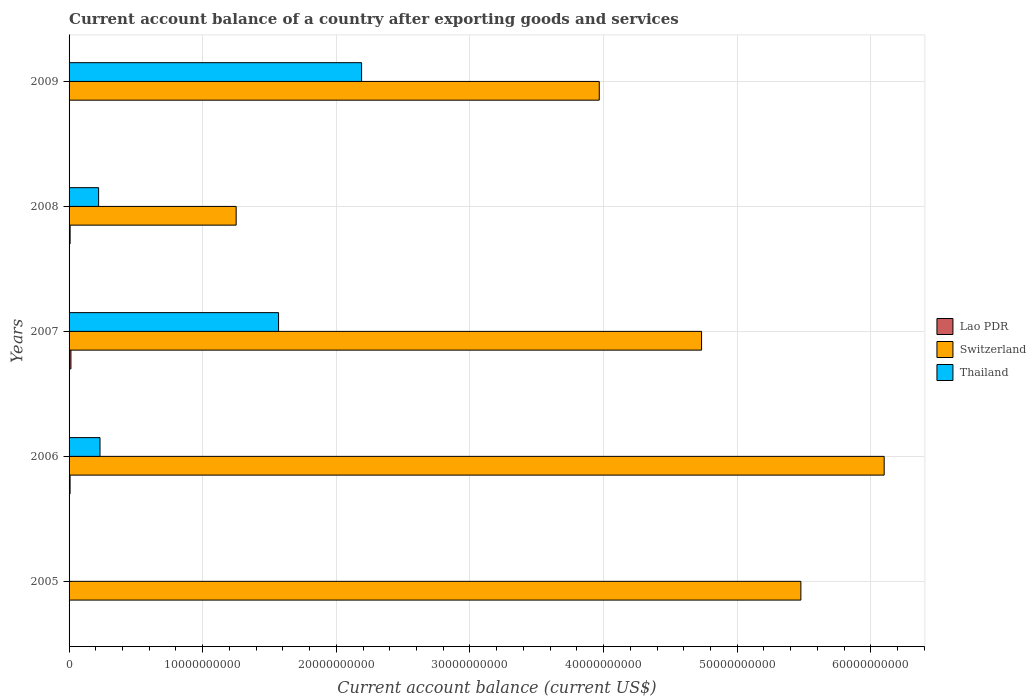How many different coloured bars are there?
Provide a short and direct response. 3. Are the number of bars per tick equal to the number of legend labels?
Your answer should be compact. No. What is the account balance in Switzerland in 2006?
Make the answer very short. 6.10e+1. Across all years, what is the maximum account balance in Lao PDR?
Your response must be concise. 1.39e+08. Across all years, what is the minimum account balance in Lao PDR?
Ensure brevity in your answer.  0. What is the total account balance in Lao PDR in the graph?
Provide a short and direct response. 2.92e+08. What is the difference between the account balance in Switzerland in 2007 and that in 2008?
Offer a very short reply. 3.48e+1. What is the difference between the account balance in Thailand in 2005 and the account balance in Lao PDR in 2009?
Offer a terse response. 0. What is the average account balance in Thailand per year?
Offer a terse response. 8.42e+09. In the year 2009, what is the difference between the account balance in Switzerland and account balance in Thailand?
Your answer should be very brief. 1.78e+1. In how many years, is the account balance in Switzerland greater than 52000000000 US$?
Ensure brevity in your answer.  2. What is the ratio of the account balance in Lao PDR in 2006 to that in 2008?
Offer a very short reply. 0.97. What is the difference between the highest and the second highest account balance in Switzerland?
Make the answer very short. 6.23e+09. What is the difference between the highest and the lowest account balance in Lao PDR?
Make the answer very short. 1.39e+08. Is it the case that in every year, the sum of the account balance in Switzerland and account balance in Lao PDR is greater than the account balance in Thailand?
Your response must be concise. Yes. How many bars are there?
Your answer should be very brief. 12. Are all the bars in the graph horizontal?
Make the answer very short. Yes. How many years are there in the graph?
Your answer should be compact. 5. What is the difference between two consecutive major ticks on the X-axis?
Offer a very short reply. 1.00e+1. Are the values on the major ticks of X-axis written in scientific E-notation?
Keep it short and to the point. No. Does the graph contain any zero values?
Provide a short and direct response. Yes. Does the graph contain grids?
Ensure brevity in your answer.  Yes. Where does the legend appear in the graph?
Make the answer very short. Center right. How many legend labels are there?
Keep it short and to the point. 3. How are the legend labels stacked?
Offer a very short reply. Vertical. What is the title of the graph?
Make the answer very short. Current account balance of a country after exporting goods and services. Does "Kuwait" appear as one of the legend labels in the graph?
Give a very brief answer. No. What is the label or title of the X-axis?
Your answer should be very brief. Current account balance (current US$). What is the Current account balance (current US$) of Lao PDR in 2005?
Provide a succinct answer. 0. What is the Current account balance (current US$) in Switzerland in 2005?
Your response must be concise. 5.48e+1. What is the Current account balance (current US$) of Lao PDR in 2006?
Your answer should be very brief. 7.53e+07. What is the Current account balance (current US$) in Switzerland in 2006?
Keep it short and to the point. 6.10e+1. What is the Current account balance (current US$) in Thailand in 2006?
Keep it short and to the point. 2.32e+09. What is the Current account balance (current US$) of Lao PDR in 2007?
Give a very brief answer. 1.39e+08. What is the Current account balance (current US$) in Switzerland in 2007?
Provide a succinct answer. 4.73e+1. What is the Current account balance (current US$) of Thailand in 2007?
Give a very brief answer. 1.57e+1. What is the Current account balance (current US$) of Lao PDR in 2008?
Offer a very short reply. 7.75e+07. What is the Current account balance (current US$) of Switzerland in 2008?
Your answer should be very brief. 1.25e+1. What is the Current account balance (current US$) in Thailand in 2008?
Provide a short and direct response. 2.21e+09. What is the Current account balance (current US$) in Lao PDR in 2009?
Offer a very short reply. 0. What is the Current account balance (current US$) of Switzerland in 2009?
Give a very brief answer. 3.97e+1. What is the Current account balance (current US$) in Thailand in 2009?
Your response must be concise. 2.19e+1. Across all years, what is the maximum Current account balance (current US$) of Lao PDR?
Keep it short and to the point. 1.39e+08. Across all years, what is the maximum Current account balance (current US$) in Switzerland?
Provide a short and direct response. 6.10e+1. Across all years, what is the maximum Current account balance (current US$) in Thailand?
Your response must be concise. 2.19e+1. Across all years, what is the minimum Current account balance (current US$) of Lao PDR?
Provide a succinct answer. 0. Across all years, what is the minimum Current account balance (current US$) in Switzerland?
Your answer should be compact. 1.25e+1. What is the total Current account balance (current US$) of Lao PDR in the graph?
Your response must be concise. 2.92e+08. What is the total Current account balance (current US$) of Switzerland in the graph?
Ensure brevity in your answer.  2.15e+11. What is the total Current account balance (current US$) of Thailand in the graph?
Keep it short and to the point. 4.21e+1. What is the difference between the Current account balance (current US$) of Switzerland in 2005 and that in 2006?
Make the answer very short. -6.23e+09. What is the difference between the Current account balance (current US$) in Switzerland in 2005 and that in 2007?
Provide a short and direct response. 7.43e+09. What is the difference between the Current account balance (current US$) of Switzerland in 2005 and that in 2008?
Provide a succinct answer. 4.23e+1. What is the difference between the Current account balance (current US$) of Switzerland in 2005 and that in 2009?
Provide a succinct answer. 1.51e+1. What is the difference between the Current account balance (current US$) of Lao PDR in 2006 and that in 2007?
Offer a terse response. -6.41e+07. What is the difference between the Current account balance (current US$) in Switzerland in 2006 and that in 2007?
Your answer should be very brief. 1.37e+1. What is the difference between the Current account balance (current US$) in Thailand in 2006 and that in 2007?
Your answer should be very brief. -1.34e+1. What is the difference between the Current account balance (current US$) of Lao PDR in 2006 and that in 2008?
Give a very brief answer. -2.24e+06. What is the difference between the Current account balance (current US$) in Switzerland in 2006 and that in 2008?
Provide a short and direct response. 4.85e+1. What is the difference between the Current account balance (current US$) in Thailand in 2006 and that in 2008?
Ensure brevity in your answer.  1.05e+08. What is the difference between the Current account balance (current US$) in Switzerland in 2006 and that in 2009?
Provide a short and direct response. 2.13e+1. What is the difference between the Current account balance (current US$) of Thailand in 2006 and that in 2009?
Provide a succinct answer. -1.96e+1. What is the difference between the Current account balance (current US$) in Lao PDR in 2007 and that in 2008?
Your answer should be very brief. 6.19e+07. What is the difference between the Current account balance (current US$) of Switzerland in 2007 and that in 2008?
Provide a short and direct response. 3.48e+1. What is the difference between the Current account balance (current US$) of Thailand in 2007 and that in 2008?
Give a very brief answer. 1.35e+1. What is the difference between the Current account balance (current US$) in Switzerland in 2007 and that in 2009?
Give a very brief answer. 7.66e+09. What is the difference between the Current account balance (current US$) of Thailand in 2007 and that in 2009?
Give a very brief answer. -6.21e+09. What is the difference between the Current account balance (current US$) of Switzerland in 2008 and that in 2009?
Keep it short and to the point. -2.72e+1. What is the difference between the Current account balance (current US$) in Thailand in 2008 and that in 2009?
Offer a terse response. -1.97e+1. What is the difference between the Current account balance (current US$) in Switzerland in 2005 and the Current account balance (current US$) in Thailand in 2006?
Ensure brevity in your answer.  5.24e+1. What is the difference between the Current account balance (current US$) of Switzerland in 2005 and the Current account balance (current US$) of Thailand in 2007?
Ensure brevity in your answer.  3.91e+1. What is the difference between the Current account balance (current US$) of Switzerland in 2005 and the Current account balance (current US$) of Thailand in 2008?
Offer a very short reply. 5.26e+1. What is the difference between the Current account balance (current US$) in Switzerland in 2005 and the Current account balance (current US$) in Thailand in 2009?
Offer a very short reply. 3.29e+1. What is the difference between the Current account balance (current US$) in Lao PDR in 2006 and the Current account balance (current US$) in Switzerland in 2007?
Provide a short and direct response. -4.73e+1. What is the difference between the Current account balance (current US$) of Lao PDR in 2006 and the Current account balance (current US$) of Thailand in 2007?
Give a very brief answer. -1.56e+1. What is the difference between the Current account balance (current US$) in Switzerland in 2006 and the Current account balance (current US$) in Thailand in 2007?
Your answer should be very brief. 4.53e+1. What is the difference between the Current account balance (current US$) in Lao PDR in 2006 and the Current account balance (current US$) in Switzerland in 2008?
Provide a short and direct response. -1.24e+1. What is the difference between the Current account balance (current US$) in Lao PDR in 2006 and the Current account balance (current US$) in Thailand in 2008?
Provide a short and direct response. -2.14e+09. What is the difference between the Current account balance (current US$) of Switzerland in 2006 and the Current account balance (current US$) of Thailand in 2008?
Your response must be concise. 5.88e+1. What is the difference between the Current account balance (current US$) in Lao PDR in 2006 and the Current account balance (current US$) in Switzerland in 2009?
Provide a short and direct response. -3.96e+1. What is the difference between the Current account balance (current US$) of Lao PDR in 2006 and the Current account balance (current US$) of Thailand in 2009?
Provide a short and direct response. -2.18e+1. What is the difference between the Current account balance (current US$) in Switzerland in 2006 and the Current account balance (current US$) in Thailand in 2009?
Provide a short and direct response. 3.91e+1. What is the difference between the Current account balance (current US$) in Lao PDR in 2007 and the Current account balance (current US$) in Switzerland in 2008?
Give a very brief answer. -1.24e+1. What is the difference between the Current account balance (current US$) of Lao PDR in 2007 and the Current account balance (current US$) of Thailand in 2008?
Your response must be concise. -2.07e+09. What is the difference between the Current account balance (current US$) of Switzerland in 2007 and the Current account balance (current US$) of Thailand in 2008?
Give a very brief answer. 4.51e+1. What is the difference between the Current account balance (current US$) in Lao PDR in 2007 and the Current account balance (current US$) in Switzerland in 2009?
Your response must be concise. -3.95e+1. What is the difference between the Current account balance (current US$) of Lao PDR in 2007 and the Current account balance (current US$) of Thailand in 2009?
Provide a short and direct response. -2.18e+1. What is the difference between the Current account balance (current US$) in Switzerland in 2007 and the Current account balance (current US$) in Thailand in 2009?
Offer a terse response. 2.54e+1. What is the difference between the Current account balance (current US$) in Lao PDR in 2008 and the Current account balance (current US$) in Switzerland in 2009?
Provide a succinct answer. -3.96e+1. What is the difference between the Current account balance (current US$) of Lao PDR in 2008 and the Current account balance (current US$) of Thailand in 2009?
Make the answer very short. -2.18e+1. What is the difference between the Current account balance (current US$) of Switzerland in 2008 and the Current account balance (current US$) of Thailand in 2009?
Keep it short and to the point. -9.39e+09. What is the average Current account balance (current US$) of Lao PDR per year?
Your response must be concise. 5.85e+07. What is the average Current account balance (current US$) in Switzerland per year?
Give a very brief answer. 4.31e+1. What is the average Current account balance (current US$) of Thailand per year?
Keep it short and to the point. 8.42e+09. In the year 2006, what is the difference between the Current account balance (current US$) of Lao PDR and Current account balance (current US$) of Switzerland?
Provide a succinct answer. -6.09e+1. In the year 2006, what is the difference between the Current account balance (current US$) of Lao PDR and Current account balance (current US$) of Thailand?
Offer a very short reply. -2.24e+09. In the year 2006, what is the difference between the Current account balance (current US$) in Switzerland and Current account balance (current US$) in Thailand?
Your response must be concise. 5.87e+1. In the year 2007, what is the difference between the Current account balance (current US$) in Lao PDR and Current account balance (current US$) in Switzerland?
Ensure brevity in your answer.  -4.72e+1. In the year 2007, what is the difference between the Current account balance (current US$) of Lao PDR and Current account balance (current US$) of Thailand?
Offer a terse response. -1.55e+1. In the year 2007, what is the difference between the Current account balance (current US$) in Switzerland and Current account balance (current US$) in Thailand?
Keep it short and to the point. 3.17e+1. In the year 2008, what is the difference between the Current account balance (current US$) in Lao PDR and Current account balance (current US$) in Switzerland?
Your answer should be compact. -1.24e+1. In the year 2008, what is the difference between the Current account balance (current US$) in Lao PDR and Current account balance (current US$) in Thailand?
Your response must be concise. -2.13e+09. In the year 2008, what is the difference between the Current account balance (current US$) of Switzerland and Current account balance (current US$) of Thailand?
Give a very brief answer. 1.03e+1. In the year 2009, what is the difference between the Current account balance (current US$) in Switzerland and Current account balance (current US$) in Thailand?
Give a very brief answer. 1.78e+1. What is the ratio of the Current account balance (current US$) of Switzerland in 2005 to that in 2006?
Your answer should be compact. 0.9. What is the ratio of the Current account balance (current US$) of Switzerland in 2005 to that in 2007?
Provide a short and direct response. 1.16. What is the ratio of the Current account balance (current US$) in Switzerland in 2005 to that in 2008?
Provide a succinct answer. 4.38. What is the ratio of the Current account balance (current US$) in Switzerland in 2005 to that in 2009?
Your answer should be very brief. 1.38. What is the ratio of the Current account balance (current US$) in Lao PDR in 2006 to that in 2007?
Your answer should be compact. 0.54. What is the ratio of the Current account balance (current US$) of Switzerland in 2006 to that in 2007?
Your response must be concise. 1.29. What is the ratio of the Current account balance (current US$) of Thailand in 2006 to that in 2007?
Offer a very short reply. 0.15. What is the ratio of the Current account balance (current US$) of Lao PDR in 2006 to that in 2008?
Your answer should be very brief. 0.97. What is the ratio of the Current account balance (current US$) in Switzerland in 2006 to that in 2008?
Make the answer very short. 4.88. What is the ratio of the Current account balance (current US$) in Thailand in 2006 to that in 2008?
Give a very brief answer. 1.05. What is the ratio of the Current account balance (current US$) in Switzerland in 2006 to that in 2009?
Offer a very short reply. 1.54. What is the ratio of the Current account balance (current US$) of Thailand in 2006 to that in 2009?
Offer a very short reply. 0.11. What is the ratio of the Current account balance (current US$) of Lao PDR in 2007 to that in 2008?
Make the answer very short. 1.8. What is the ratio of the Current account balance (current US$) in Switzerland in 2007 to that in 2008?
Offer a terse response. 3.79. What is the ratio of the Current account balance (current US$) in Thailand in 2007 to that in 2008?
Make the answer very short. 7.09. What is the ratio of the Current account balance (current US$) of Switzerland in 2007 to that in 2009?
Your answer should be very brief. 1.19. What is the ratio of the Current account balance (current US$) in Thailand in 2007 to that in 2009?
Provide a succinct answer. 0.72. What is the ratio of the Current account balance (current US$) of Switzerland in 2008 to that in 2009?
Ensure brevity in your answer.  0.32. What is the ratio of the Current account balance (current US$) in Thailand in 2008 to that in 2009?
Ensure brevity in your answer.  0.1. What is the difference between the highest and the second highest Current account balance (current US$) in Lao PDR?
Your response must be concise. 6.19e+07. What is the difference between the highest and the second highest Current account balance (current US$) of Switzerland?
Offer a terse response. 6.23e+09. What is the difference between the highest and the second highest Current account balance (current US$) in Thailand?
Your answer should be compact. 6.21e+09. What is the difference between the highest and the lowest Current account balance (current US$) of Lao PDR?
Your answer should be compact. 1.39e+08. What is the difference between the highest and the lowest Current account balance (current US$) in Switzerland?
Your response must be concise. 4.85e+1. What is the difference between the highest and the lowest Current account balance (current US$) of Thailand?
Your answer should be very brief. 2.19e+1. 